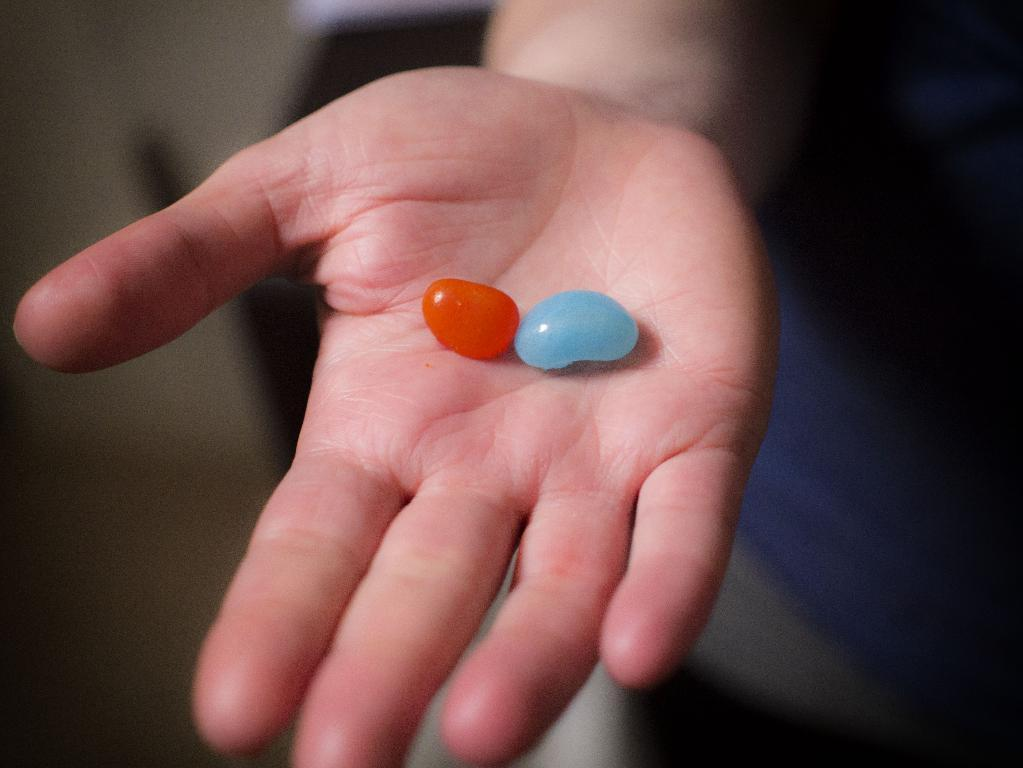What is the focus of the image? The image is zoomed in on a hand of a person. What is the hand doing in the image? The hand is holding some objects. How is the background of the image depicted? The background of the image is blurry. Can you describe any items visible in the background? There are some items visible in the background. What type of wheel can be seen in the image? There is no wheel present in the image. Is there a crib visible in the image? There is no crib present in the image. 